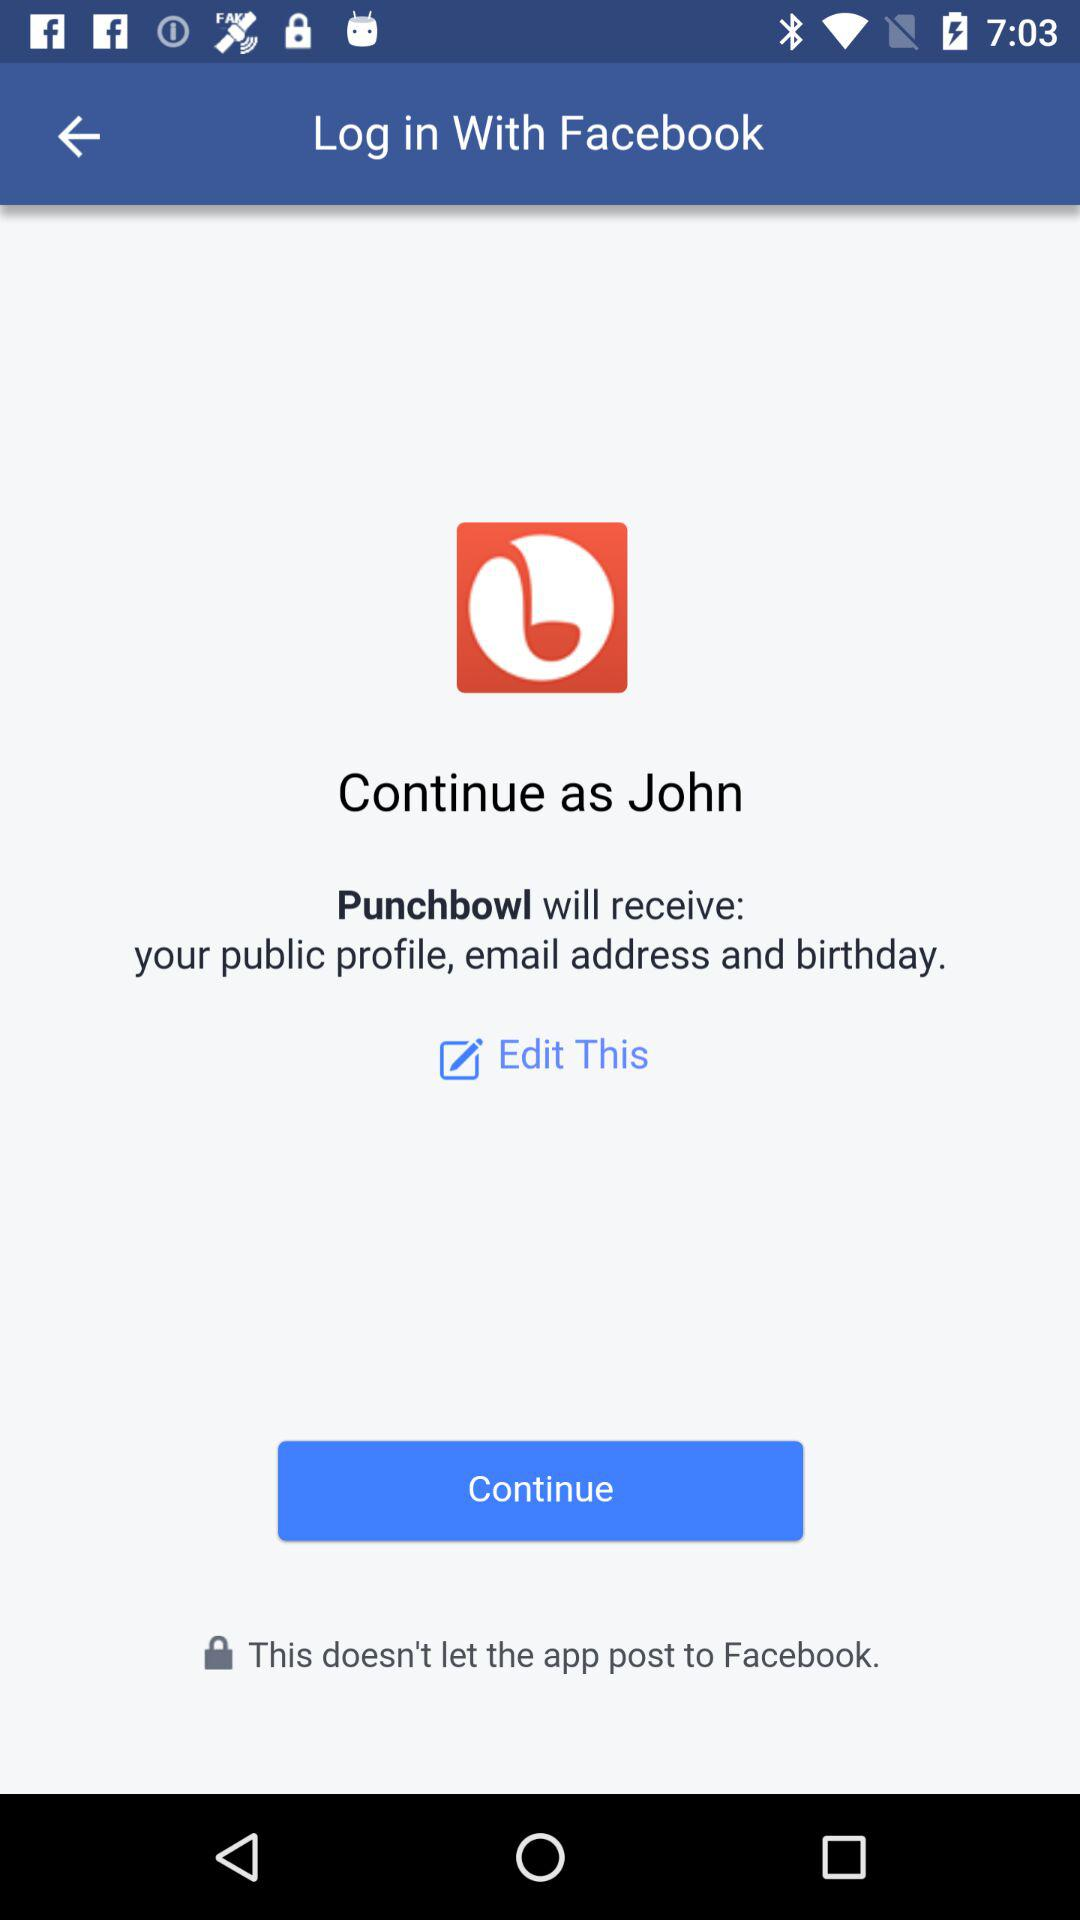What is the name of the user? The name of the user is "John". 